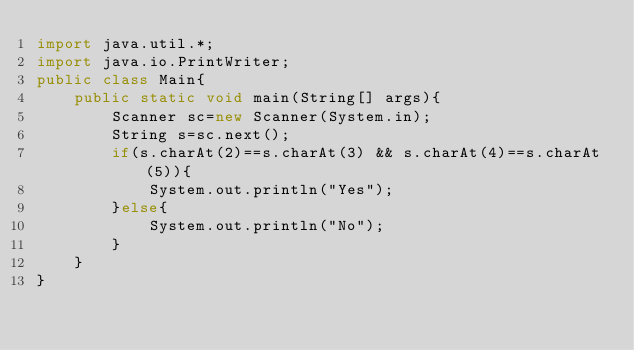<code> <loc_0><loc_0><loc_500><loc_500><_Java_>import java.util.*;
import java.io.PrintWriter;
public class Main{
	public static void main(String[] args){
		Scanner sc=new Scanner(System.in);
		String s=sc.next();
		if(s.charAt(2)==s.charAt(3) && s.charAt(4)==s.charAt(5)){
			System.out.println("Yes");
		}else{
			System.out.println("No");
		}
	}
}
</code> 